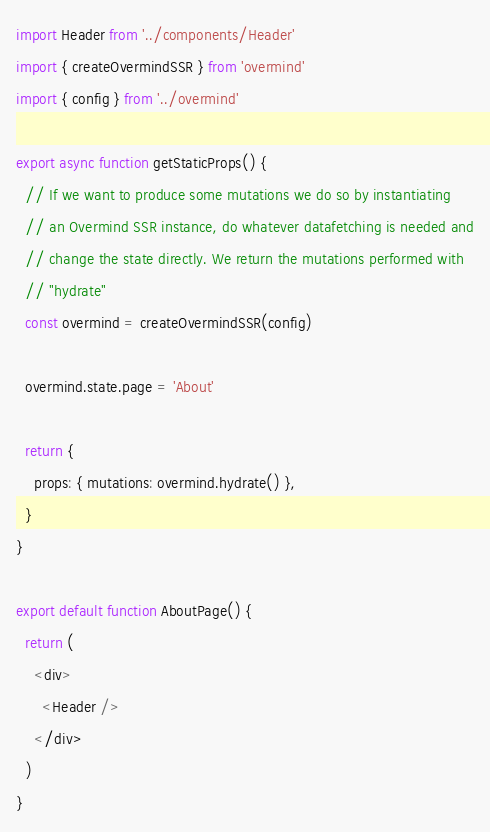Convert code to text. <code><loc_0><loc_0><loc_500><loc_500><_JavaScript_>import Header from '../components/Header'
import { createOvermindSSR } from 'overmind'
import { config } from '../overmind'

export async function getStaticProps() {
  // If we want to produce some mutations we do so by instantiating
  // an Overmind SSR instance, do whatever datafetching is needed and
  // change the state directly. We return the mutations performed with
  // "hydrate"
  const overmind = createOvermindSSR(config)

  overmind.state.page = 'About'

  return {
    props: { mutations: overmind.hydrate() },
  }
}

export default function AboutPage() {
  return (
    <div>
      <Header />
    </div>
  )
}
</code> 